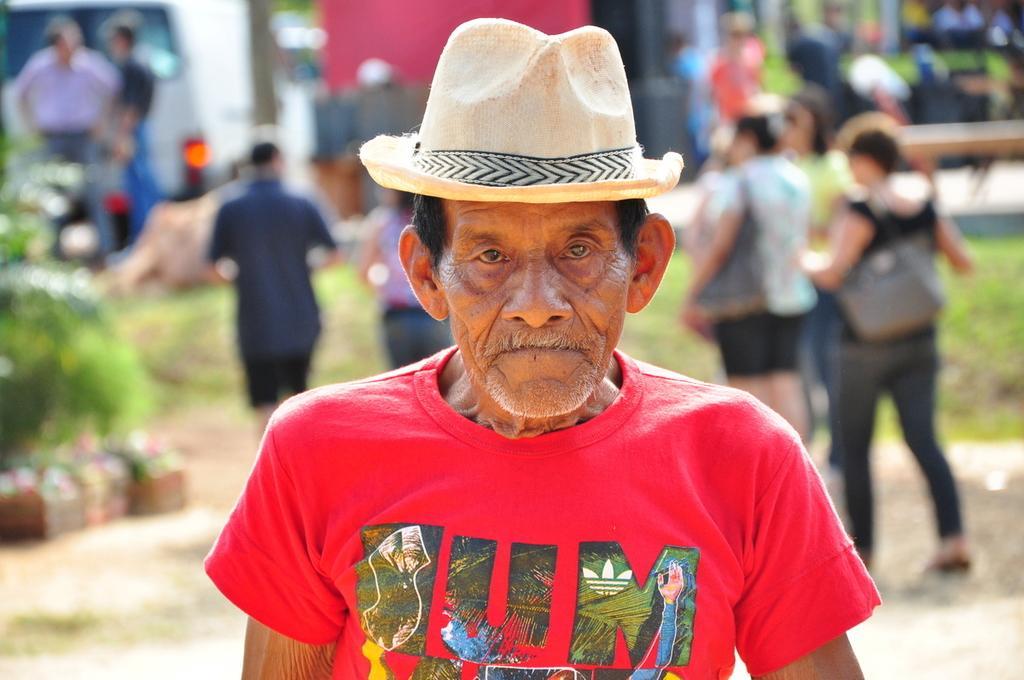How would you summarize this image in a sentence or two? In this image in the foreground we can see there is an old man wearing hat and red T Shirt. 